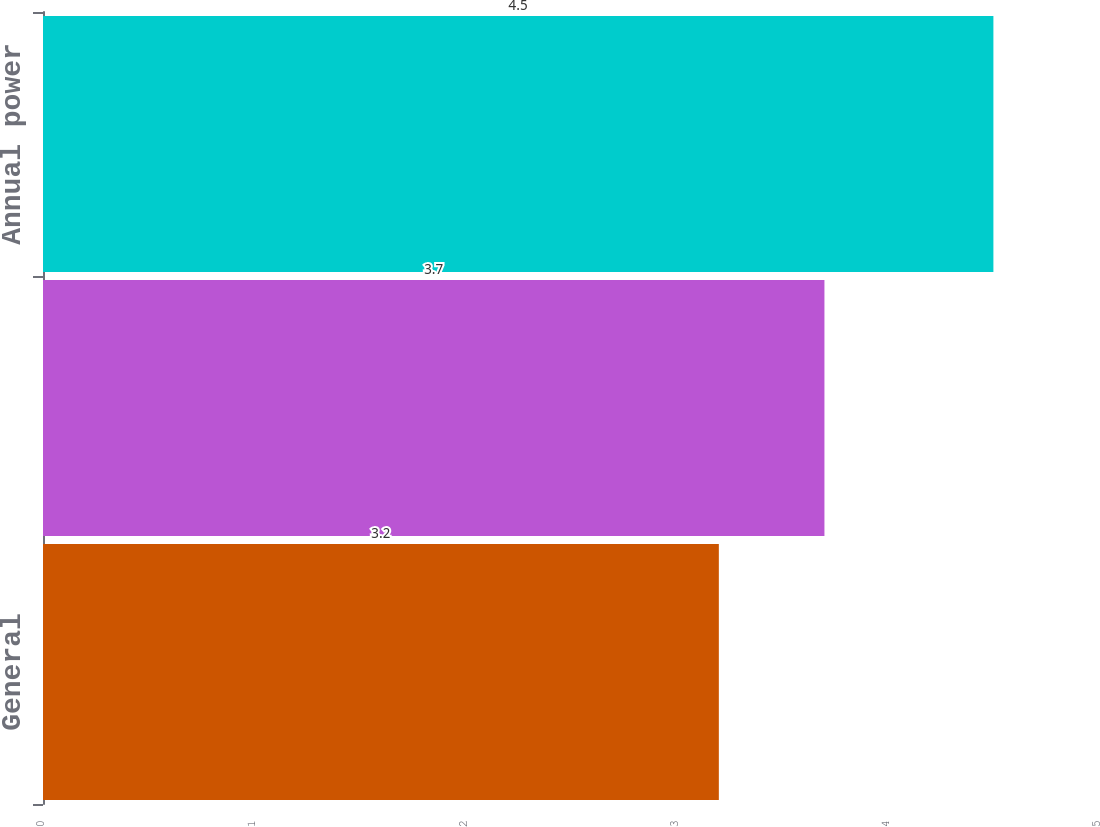Convert chart. <chart><loc_0><loc_0><loc_500><loc_500><bar_chart><fcel>General<fcel>Apartment house<fcel>Annual power<nl><fcel>3.2<fcel>3.7<fcel>4.5<nl></chart> 